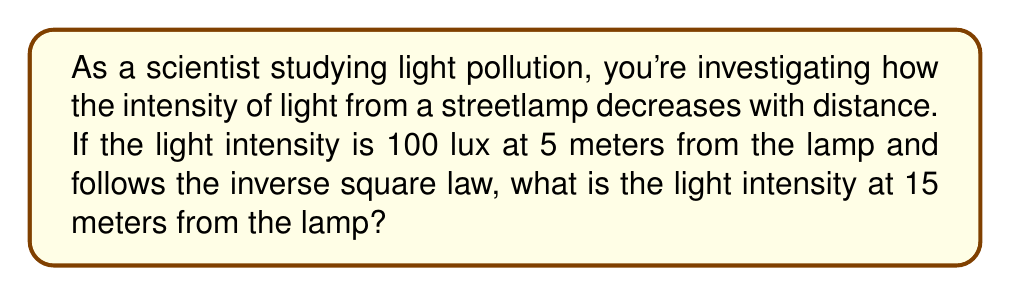Teach me how to tackle this problem. Let's approach this step-by-step:

1) The inverse square law states that the intensity of light is inversely proportional to the square of the distance from the source. We can express this mathematically as:

   $$I \propto \frac{1}{d^2}$$

   where $I$ is the intensity and $d$ is the distance.

2) We can write this as an equation with a constant $k$:

   $$I = \frac{k}{d^2}$$

3) We know two points: (5m, 100 lux) and (15m, x lux). Let's use the first point to find $k$:

   $$100 = \frac{k}{5^2}$$
   $$k = 100 \cdot 5^2 = 2500$$

4) Now we can use this $k$ value to find the intensity at 15m:

   $$I = \frac{2500}{15^2}$$

5) Let's calculate this:

   $$I = \frac{2500}{225} = 11.11 \text{ lux}$$

Thus, the light intensity at 15 meters from the lamp is approximately 11.11 lux.
Answer: $11.11 \text{ lux}$ 